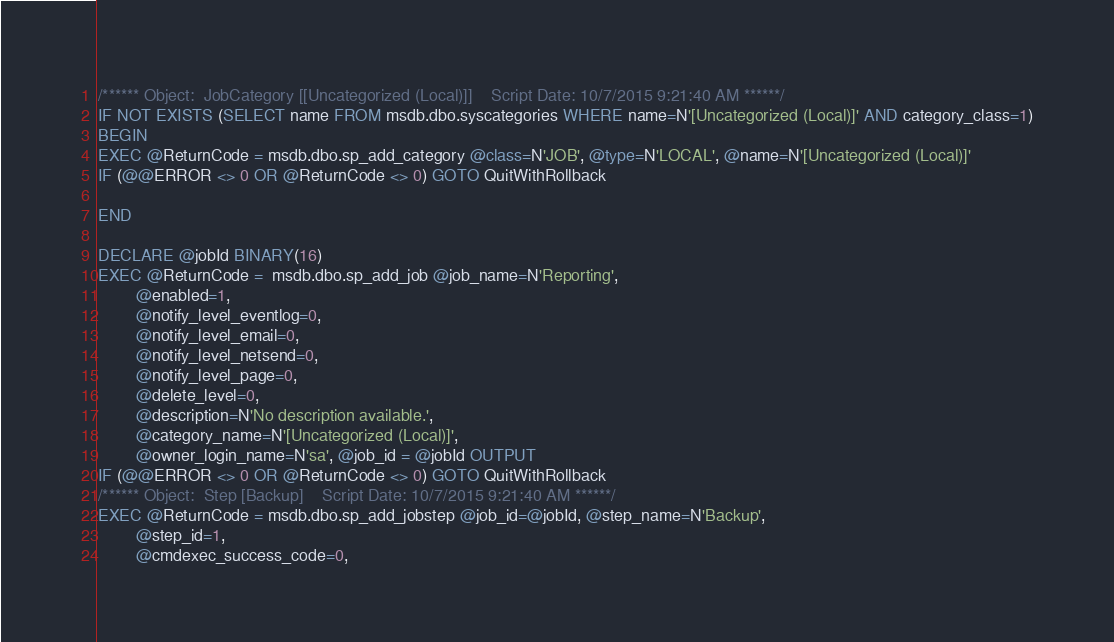Convert code to text. <code><loc_0><loc_0><loc_500><loc_500><_SQL_>/****** Object:  JobCategory [[Uncategorized (Local)]]    Script Date: 10/7/2015 9:21:40 AM ******/
IF NOT EXISTS (SELECT name FROM msdb.dbo.syscategories WHERE name=N'[Uncategorized (Local)]' AND category_class=1)
BEGIN
EXEC @ReturnCode = msdb.dbo.sp_add_category @class=N'JOB', @type=N'LOCAL', @name=N'[Uncategorized (Local)]'
IF (@@ERROR <> 0 OR @ReturnCode <> 0) GOTO QuitWithRollback

END

DECLARE @jobId BINARY(16)
EXEC @ReturnCode =  msdb.dbo.sp_add_job @job_name=N'Reporting', 
		@enabled=1, 
		@notify_level_eventlog=0, 
		@notify_level_email=0, 
		@notify_level_netsend=0, 
		@notify_level_page=0, 
		@delete_level=0, 
		@description=N'No description available.', 
		@category_name=N'[Uncategorized (Local)]', 
		@owner_login_name=N'sa', @job_id = @jobId OUTPUT
IF (@@ERROR <> 0 OR @ReturnCode <> 0) GOTO QuitWithRollback
/****** Object:  Step [Backup]    Script Date: 10/7/2015 9:21:40 AM ******/
EXEC @ReturnCode = msdb.dbo.sp_add_jobstep @job_id=@jobId, @step_name=N'Backup', 
		@step_id=1, 
		@cmdexec_success_code=0, </code> 